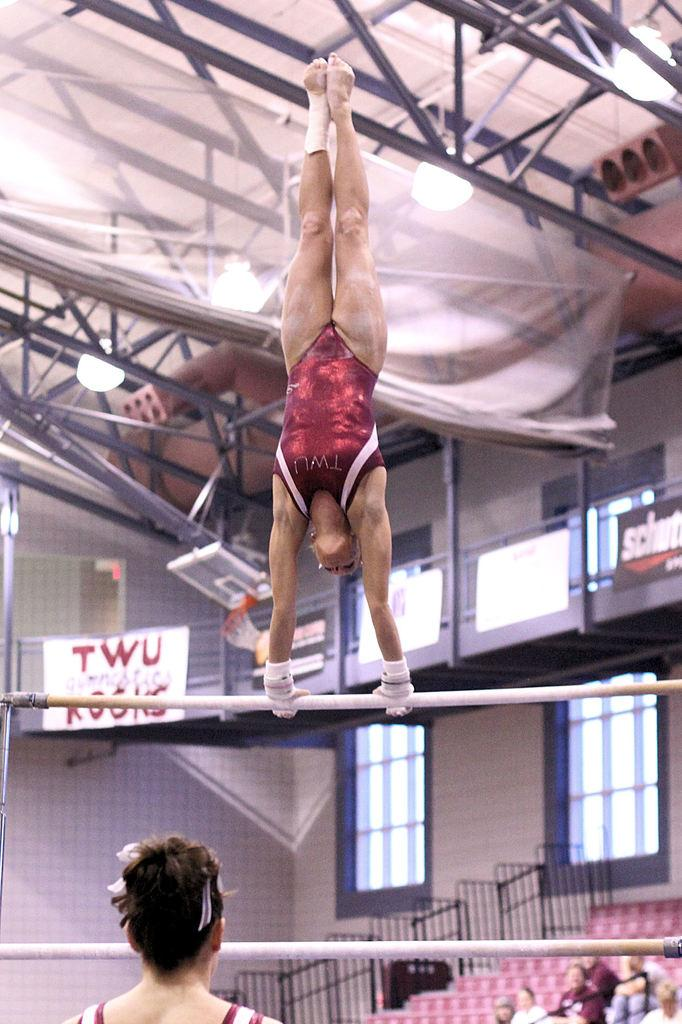<image>
Offer a succinct explanation of the picture presented. A gymnast doing a handstand on the bars in the TWU gym 